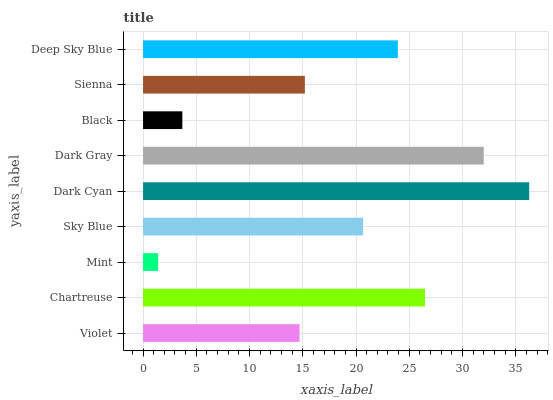Is Mint the minimum?
Answer yes or no. Yes. Is Dark Cyan the maximum?
Answer yes or no. Yes. Is Chartreuse the minimum?
Answer yes or no. No. Is Chartreuse the maximum?
Answer yes or no. No. Is Chartreuse greater than Violet?
Answer yes or no. Yes. Is Violet less than Chartreuse?
Answer yes or no. Yes. Is Violet greater than Chartreuse?
Answer yes or no. No. Is Chartreuse less than Violet?
Answer yes or no. No. Is Sky Blue the high median?
Answer yes or no. Yes. Is Sky Blue the low median?
Answer yes or no. Yes. Is Black the high median?
Answer yes or no. No. Is Dark Gray the low median?
Answer yes or no. No. 